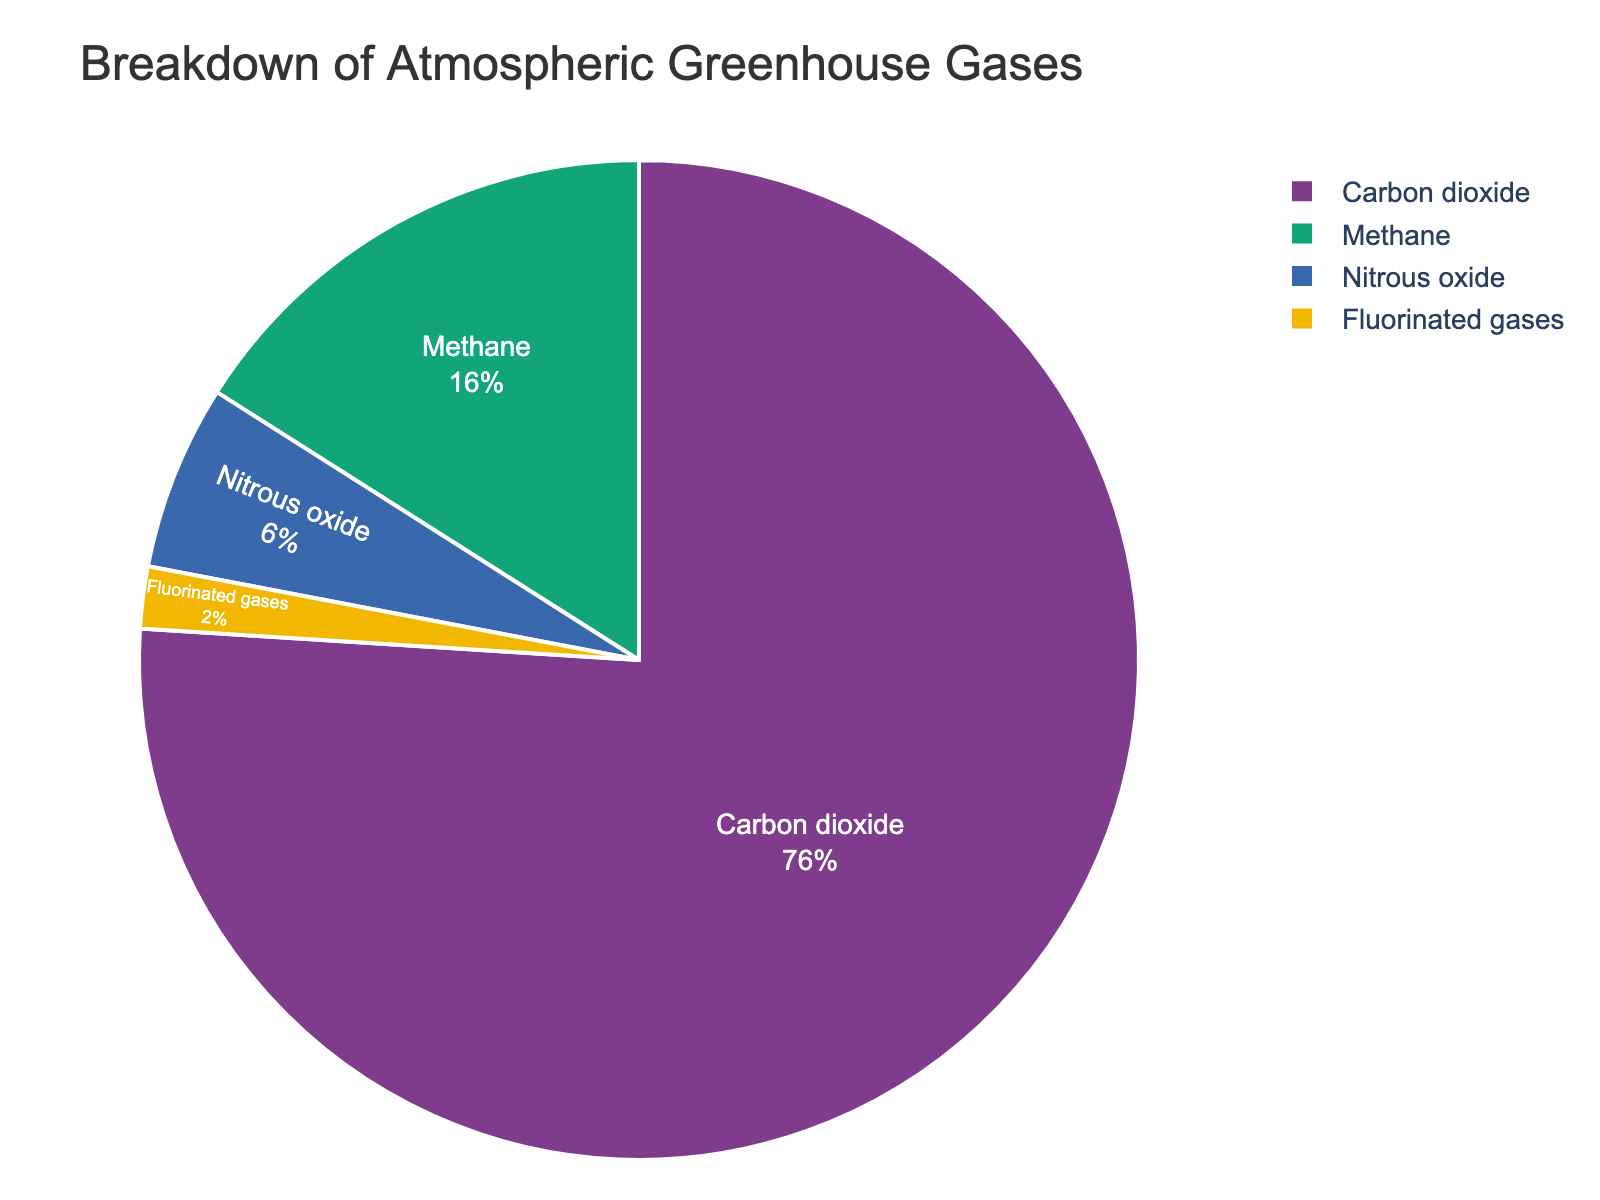What percentage of greenhouse gases does Methane contribute? Methane's contribution is shown directly on the pie chart as one of the segments. The chart indicates that Methane contributes 16%.
Answer: 16% Which greenhouse gas contributes the most to global warming? By observing the pie chart, the Carbon dioxide segment occupies the largest portion. Therefore, Carbon dioxide contributes the most to global warming.
Answer: Carbon dioxide Which segments are closest in their percentage contributions? By comparing the sizes of the segments, Nitrous oxide at 6% and Fluorinated gases at 2% appear close in value relative to others that have larger gaps between their percentages.
Answer: Nitrous oxide and Fluorinated gases What's the combined contribution of Carbon dioxide and Methane? Add the percentages of Carbon dioxide (76%) and Methane (16%) together: 76 + 16 = 92%.
Answer: 92% How much more does Carbon dioxide contribute compared to Nitrous oxide? Subtract the percentage of Nitrous oxide (6%) from Carbon dioxide (76%): 76 - 6 = 70%.
Answer: 70% Which color represents Fluorinated gases in the chart? By inspecting the colors and legends in the pie chart, Fluorinated gases are associated with a specific color segment. The chart shows Fluorinated gases in a segment, which appears to be green.
Answer: Green Which gas has the smallest contribution, and what percentage does it represent? From the pie chart, the segment for Fluorinated gases is the smallest. According to the legend, Fluorinated gases contribute 2%.
Answer: Fluorinated gases, 2% Is Methane's percentage contribution more than double that of Fluorinated gases? Methane's contribution is 16% and Fluorinated gases contribute 2%. To determine if 16% is more than double 2%, we calculate double 2%: 2 * 2 = 4%. Since 16% > 4%, Methane's contribution is indeed more than double.
Answer: Yes What's the total percentage of greenhouse gases accounted for in the chart? Summing up all the percentages given in the chart: 76 (Carbon dioxide) + 16 (Methane) + 6 (Nitrous oxide) + 2 (Fluorinated gases) = 100%.
Answer: 100% 